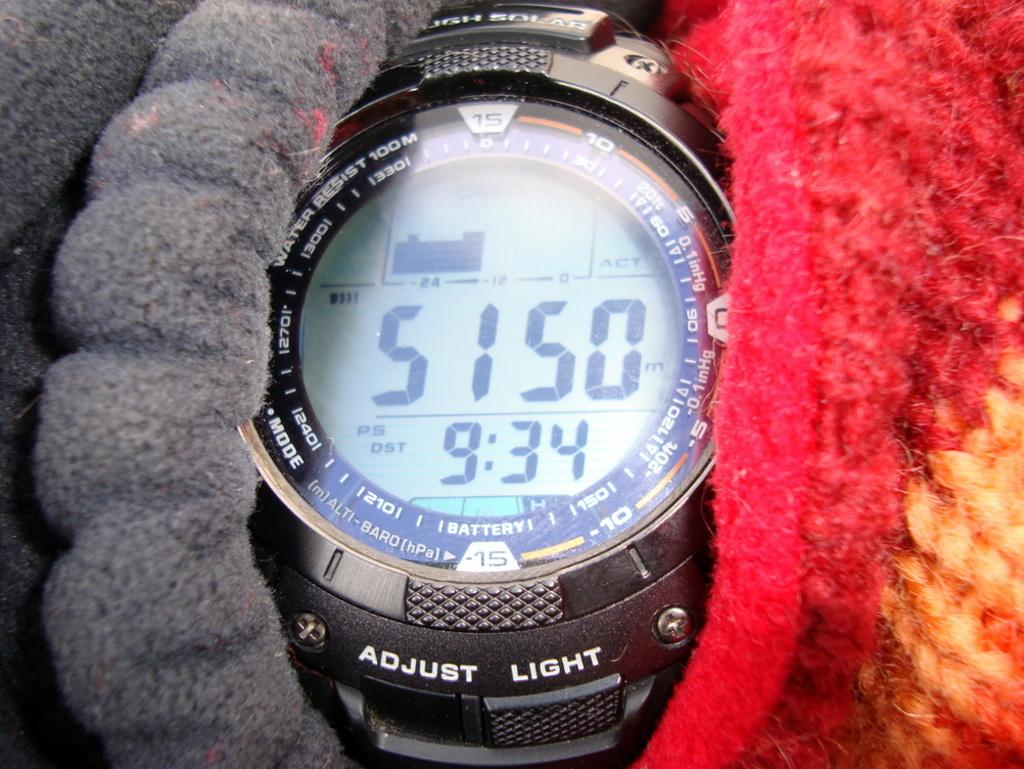<image>
Present a compact description of the photo's key features. A watch with the option to adjust light 